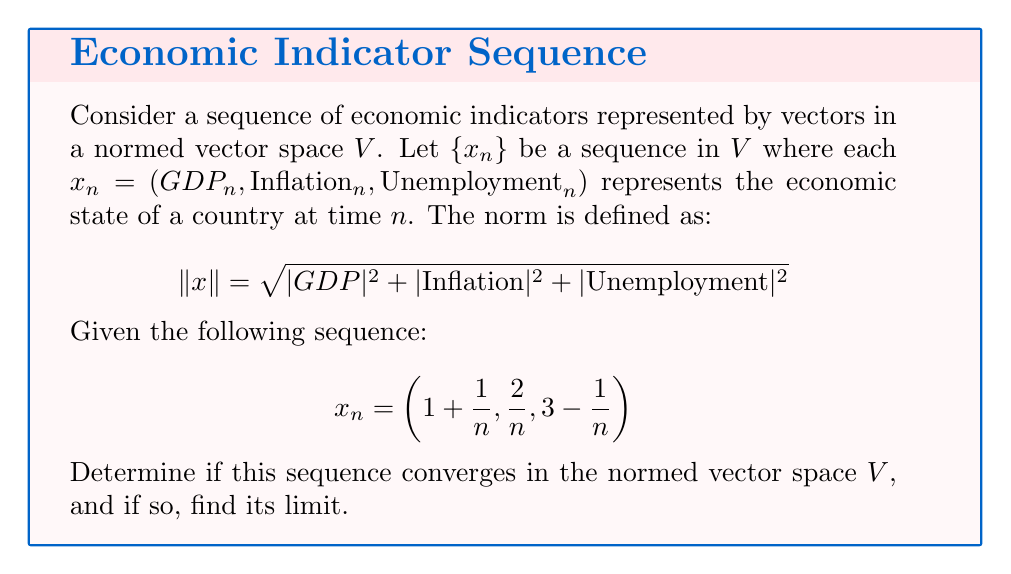Help me with this question. To analyze the convergence of this sequence, we'll follow these steps:

1) First, we need to determine if the sequence has a limit. Let's examine each component:

   $GDP_n = 1 + \frac{1}{n} \to 1$ as $n \to \infty$
   $Inflation_n = \frac{2}{n} \to 0$ as $n \to \infty$
   $Unemployment_n = 3 - \frac{1}{n} \to 3$ as $n \to \infty$

   So, if the sequence converges, its limit should be $x = (1, 0, 3)$.

2) Now, we need to prove that $\|x_n - x\| \to 0$ as $n \to \infty$:

   $$\begin{align}
   \|x_n - x\| &= \left\|\left(1 + \frac{1}{n}, \frac{2}{n}, 3 - \frac{1}{n}\right) - (1, 0, 3)\right\| \\
   &= \left\|\left(\frac{1}{n}, \frac{2}{n}, -\frac{1}{n}\right)\right\| \\
   &= \sqrt{\left(\frac{1}{n}\right)^2 + \left(\frac{2}{n}\right)^2 + \left(-\frac{1}{n}\right)^2} \\
   &= \sqrt{\frac{1}{n^2} + \frac{4}{n^2} + \frac{1}{n^2}} \\
   &= \sqrt{\frac{6}{n^2}} \\
   &= \frac{\sqrt{6}}{n}
   \end{align}$$

3) As $n \to \infty$, $\frac{\sqrt{6}}{n} \to 0$.

Therefore, the sequence converges to $x = (1, 0, 3)$ in the normed vector space $V$.
Answer: The sequence converges to $(1, 0, 3)$. 